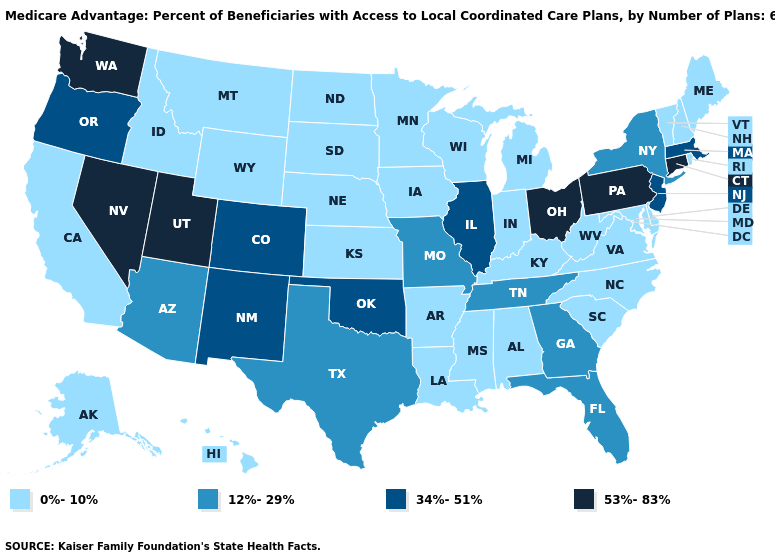What is the highest value in the USA?
Be succinct. 53%-83%. What is the lowest value in the USA?
Short answer required. 0%-10%. Which states have the lowest value in the MidWest?
Keep it brief. Iowa, Indiana, Kansas, Michigan, Minnesota, North Dakota, Nebraska, South Dakota, Wisconsin. What is the value of Colorado?
Answer briefly. 34%-51%. Which states have the highest value in the USA?
Quick response, please. Connecticut, Nevada, Ohio, Pennsylvania, Utah, Washington. What is the value of Indiana?
Give a very brief answer. 0%-10%. What is the lowest value in the USA?
Answer briefly. 0%-10%. Among the states that border Delaware , which have the highest value?
Keep it brief. Pennsylvania. How many symbols are there in the legend?
Write a very short answer. 4. Among the states that border Florida , which have the lowest value?
Quick response, please. Alabama. Among the states that border Nebraska , does Colorado have the highest value?
Quick response, please. Yes. Which states hav the highest value in the West?
Give a very brief answer. Nevada, Utah, Washington. Among the states that border Louisiana , does Mississippi have the lowest value?
Write a very short answer. Yes. Is the legend a continuous bar?
Answer briefly. No. What is the value of Oklahoma?
Short answer required. 34%-51%. 